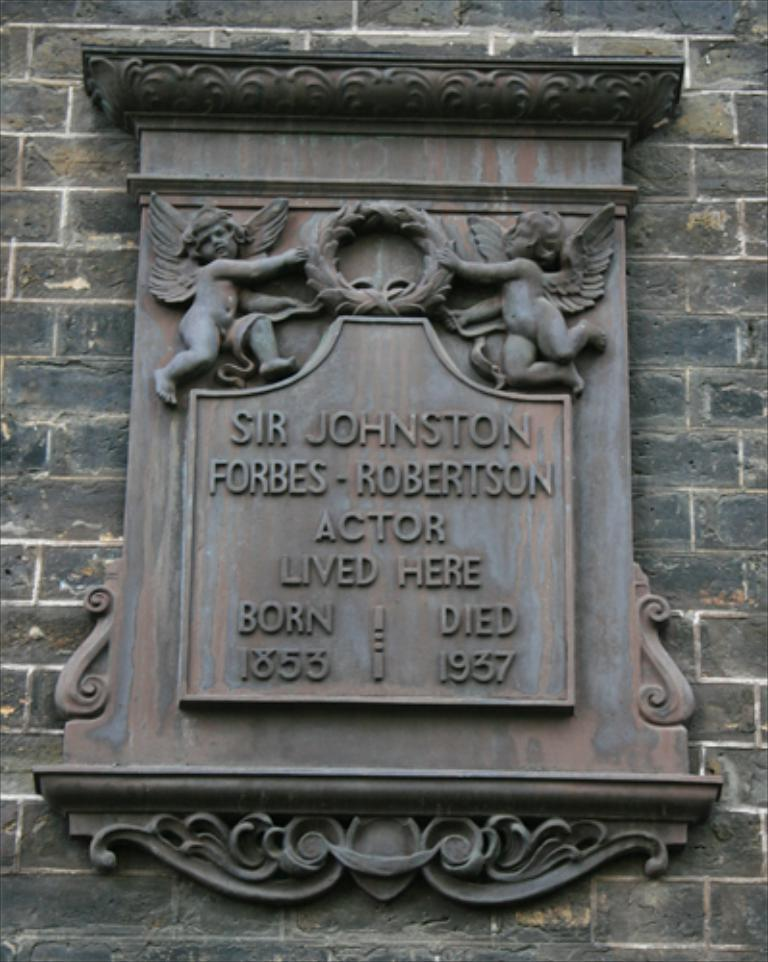What is the main subject in the image? There is a statue in the image. Where is the statue located? The statue is on the wall. What is featured on the statue? There is text engraved on the statue. What is the income of the fairies depicted on the statue? There are no fairies depicted on the statue, and therefore no information about their income can be provided. What type of smell is associated with the statue in the image? There is no mention of any smell associated with the statue in the image. 